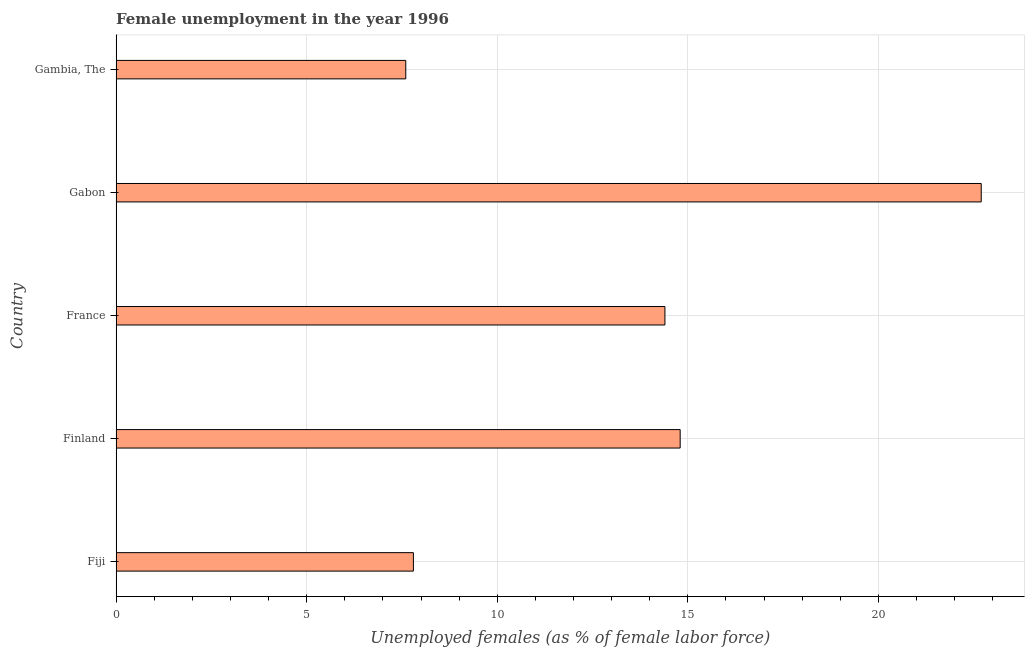Does the graph contain any zero values?
Provide a succinct answer. No. What is the title of the graph?
Offer a terse response. Female unemployment in the year 1996. What is the label or title of the X-axis?
Your response must be concise. Unemployed females (as % of female labor force). What is the label or title of the Y-axis?
Make the answer very short. Country. What is the unemployed females population in Gabon?
Your answer should be compact. 22.7. Across all countries, what is the maximum unemployed females population?
Keep it short and to the point. 22.7. Across all countries, what is the minimum unemployed females population?
Ensure brevity in your answer.  7.6. In which country was the unemployed females population maximum?
Your answer should be compact. Gabon. In which country was the unemployed females population minimum?
Make the answer very short. Gambia, The. What is the sum of the unemployed females population?
Provide a short and direct response. 67.3. What is the difference between the unemployed females population in Finland and France?
Offer a very short reply. 0.4. What is the average unemployed females population per country?
Give a very brief answer. 13.46. What is the median unemployed females population?
Offer a terse response. 14.4. What is the ratio of the unemployed females population in Gabon to that in Gambia, The?
Ensure brevity in your answer.  2.99. Is the unemployed females population in Gabon less than that in Gambia, The?
Give a very brief answer. No. Is the difference between the unemployed females population in France and Gabon greater than the difference between any two countries?
Make the answer very short. No. What is the difference between the highest and the second highest unemployed females population?
Your answer should be compact. 7.9. Is the sum of the unemployed females population in France and Gabon greater than the maximum unemployed females population across all countries?
Make the answer very short. Yes. What is the difference between the highest and the lowest unemployed females population?
Make the answer very short. 15.1. Are all the bars in the graph horizontal?
Give a very brief answer. Yes. What is the difference between two consecutive major ticks on the X-axis?
Give a very brief answer. 5. Are the values on the major ticks of X-axis written in scientific E-notation?
Make the answer very short. No. What is the Unemployed females (as % of female labor force) of Fiji?
Your response must be concise. 7.8. What is the Unemployed females (as % of female labor force) in Finland?
Keep it short and to the point. 14.8. What is the Unemployed females (as % of female labor force) of France?
Your answer should be compact. 14.4. What is the Unemployed females (as % of female labor force) in Gabon?
Provide a short and direct response. 22.7. What is the Unemployed females (as % of female labor force) of Gambia, The?
Your answer should be very brief. 7.6. What is the difference between the Unemployed females (as % of female labor force) in Fiji and France?
Your answer should be compact. -6.6. What is the difference between the Unemployed females (as % of female labor force) in Fiji and Gabon?
Keep it short and to the point. -14.9. What is the difference between the Unemployed females (as % of female labor force) in Finland and France?
Ensure brevity in your answer.  0.4. What is the difference between the Unemployed females (as % of female labor force) in Finland and Gabon?
Offer a terse response. -7.9. What is the difference between the Unemployed females (as % of female labor force) in Finland and Gambia, The?
Offer a terse response. 7.2. What is the difference between the Unemployed females (as % of female labor force) in France and Gambia, The?
Your answer should be compact. 6.8. What is the ratio of the Unemployed females (as % of female labor force) in Fiji to that in Finland?
Ensure brevity in your answer.  0.53. What is the ratio of the Unemployed females (as % of female labor force) in Fiji to that in France?
Provide a short and direct response. 0.54. What is the ratio of the Unemployed females (as % of female labor force) in Fiji to that in Gabon?
Make the answer very short. 0.34. What is the ratio of the Unemployed females (as % of female labor force) in Finland to that in France?
Your response must be concise. 1.03. What is the ratio of the Unemployed females (as % of female labor force) in Finland to that in Gabon?
Provide a short and direct response. 0.65. What is the ratio of the Unemployed females (as % of female labor force) in Finland to that in Gambia, The?
Offer a terse response. 1.95. What is the ratio of the Unemployed females (as % of female labor force) in France to that in Gabon?
Ensure brevity in your answer.  0.63. What is the ratio of the Unemployed females (as % of female labor force) in France to that in Gambia, The?
Your answer should be compact. 1.9. What is the ratio of the Unemployed females (as % of female labor force) in Gabon to that in Gambia, The?
Your answer should be compact. 2.99. 